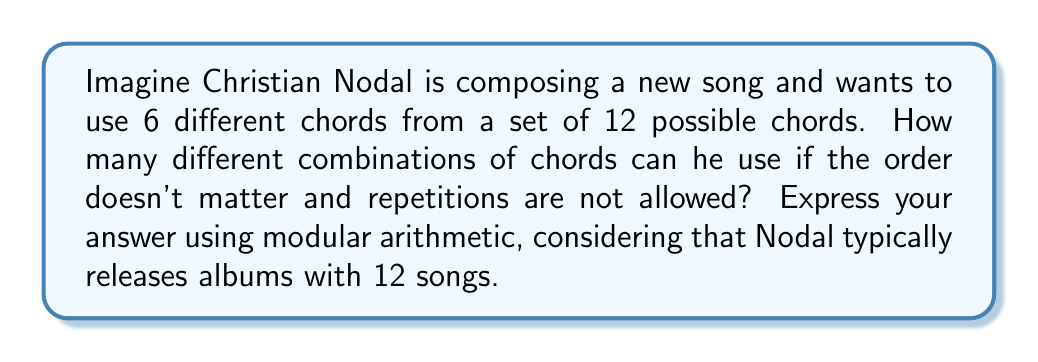Help me with this question. Let's approach this step-by-step:

1) This is a combination problem. We're choosing 6 chords from 12 possible chords, where order doesn't matter and repetitions are not allowed.

2) The formula for this combination is:

   $$C(12,6) = \frac{12!}{6!(12-6)!} = \frac{12!}{6!6!}$$

3) Let's calculate this:
   
   $$\frac{12 \cdot 11 \cdot 10 \cdot 9 \cdot 8 \cdot 7}{6 \cdot 5 \cdot 4 \cdot 3 \cdot 2 \cdot 1} = 924$$

4) Now, we need to express this using modular arithmetic, considering that Nodal typically releases albums with 12 songs.

5) In modular arithmetic with modulus 12, we can write:

   $$924 \equiv x \pmod{12}$$

6) To find x, we can divide 924 by 12:
   
   $$924 = 77 \cdot 12 + 0$$

7) Therefore, in modular arithmetic with modulus 12:

   $$924 \equiv 0 \pmod{12}$$

This means that the number of combinations is equivalent to 0 when considering albums of 12 songs.
Answer: $0 \pmod{12}$ 